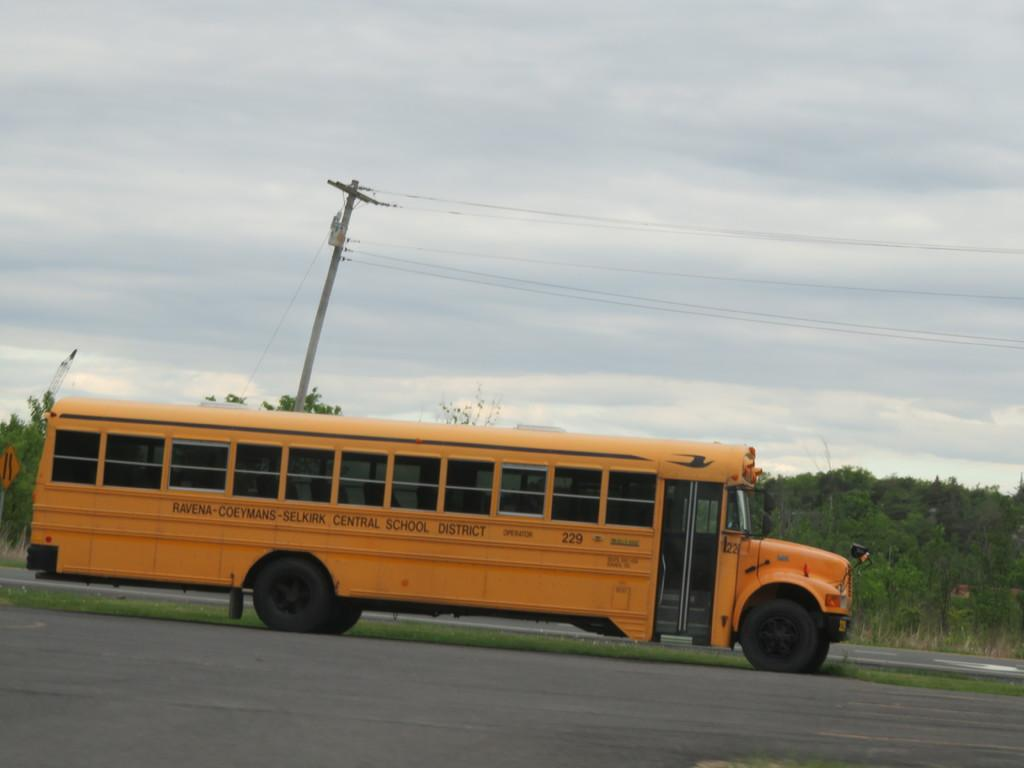What is the main feature of the image? There is a road in the image. Can you describe any vehicles in the image? There is a vehicle with text on it in the image. What can be seen in the background of the image? There are trees, an electric pole, and clouds in the sky in the background of the image. How many snails can be seen crawling on the electric pole in the image? There are no snails present in the image, and therefore none can be seen crawling on the electric pole. 